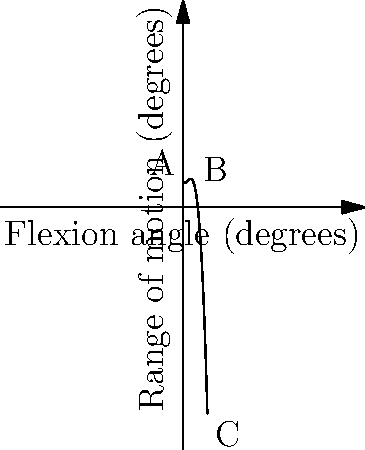The graph shows the range of motion curve for a prosthetic knee joint. At which point does the prosthetic knee joint exhibit the maximum range of motion, and what is the approximate flexion angle at this point? To find the maximum range of motion and its corresponding flexion angle, we need to analyze the curve:

1. The curve represents the relationship between the flexion angle (x-axis) and the range of motion (y-axis) for the prosthetic knee joint.

2. The maximum range of motion occurs at the highest point of the curve.

3. By observing the graph, we can see that the curve reaches its peak near point B.

4. Point B is located approximately at a flexion angle of 30 degrees.

5. At this point, the range of motion appears to be at its maximum value.

Therefore, the prosthetic knee joint exhibits the maximum range of motion at point B, which corresponds to a flexion angle of approximately 30 degrees.
Answer: Point B, 30 degrees 